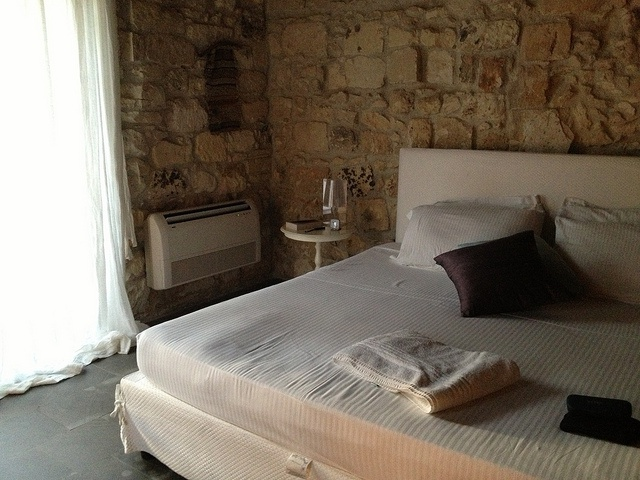Describe the objects in this image and their specific colors. I can see bed in white, gray, darkgray, and black tones, vase in white, black, gray, and maroon tones, book in white, black, and gray tones, and clock in white, gray, black, and darkgray tones in this image. 